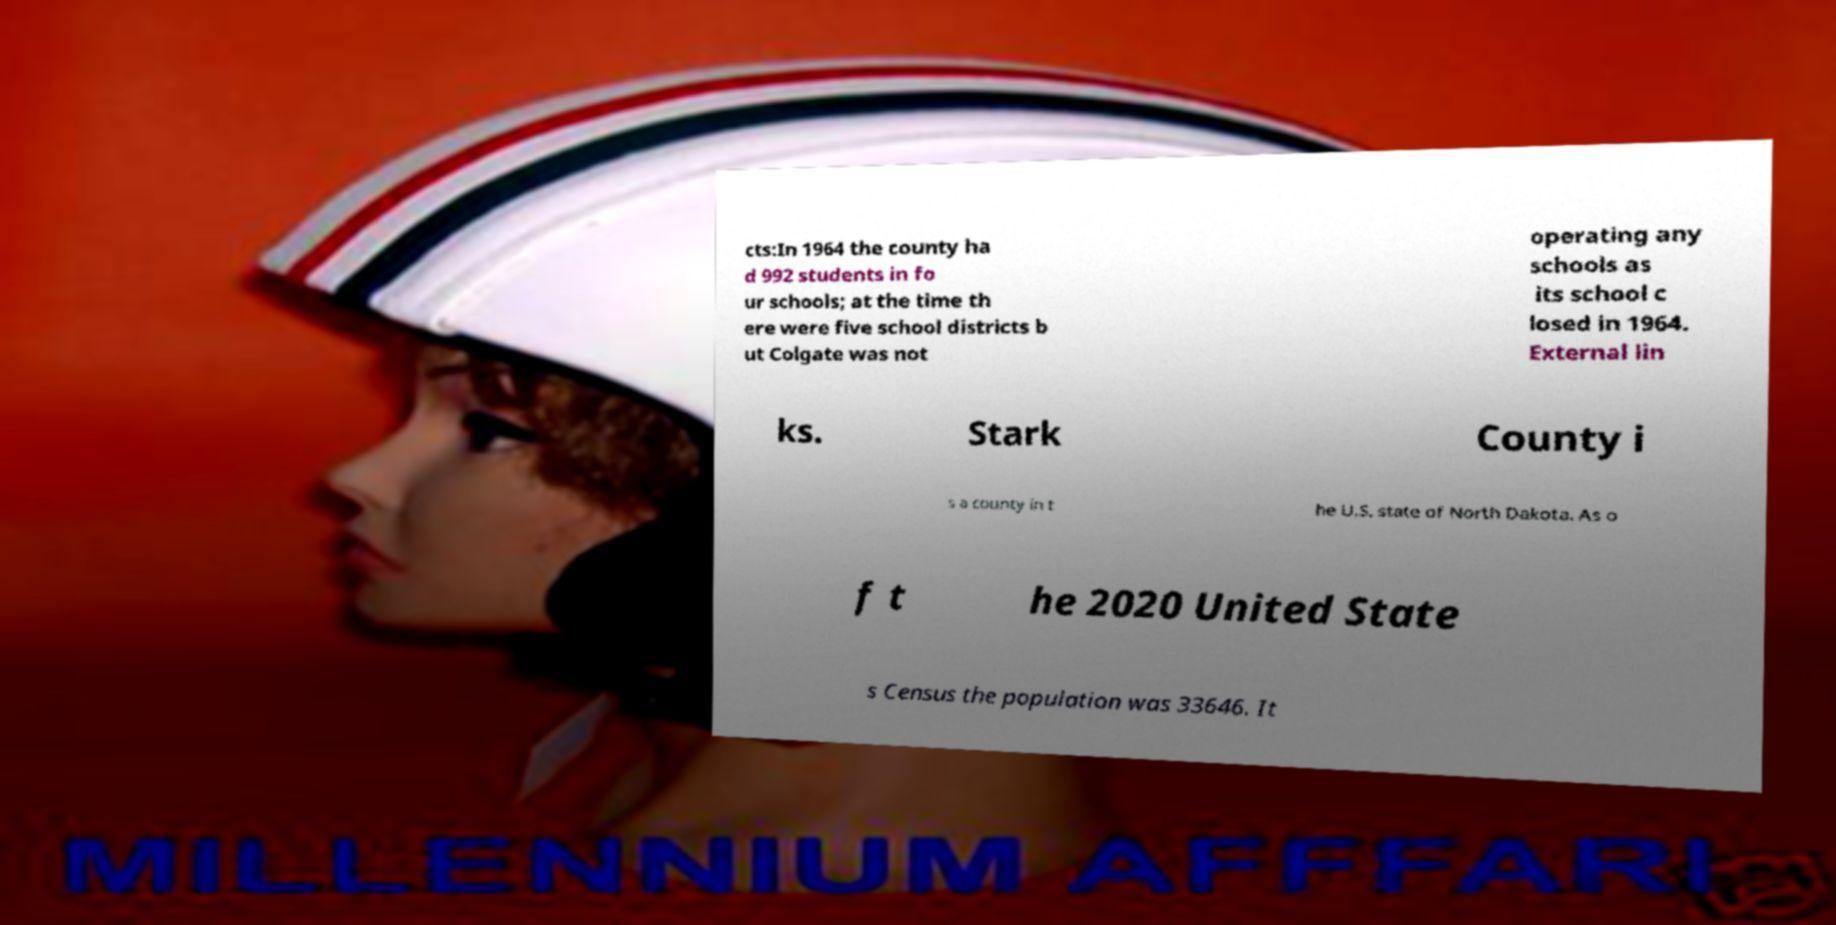Please identify and transcribe the text found in this image. cts:In 1964 the county ha d 992 students in fo ur schools; at the time th ere were five school districts b ut Colgate was not operating any schools as its school c losed in 1964. External lin ks. Stark County i s a county in t he U.S. state of North Dakota. As o f t he 2020 United State s Census the population was 33646. It 